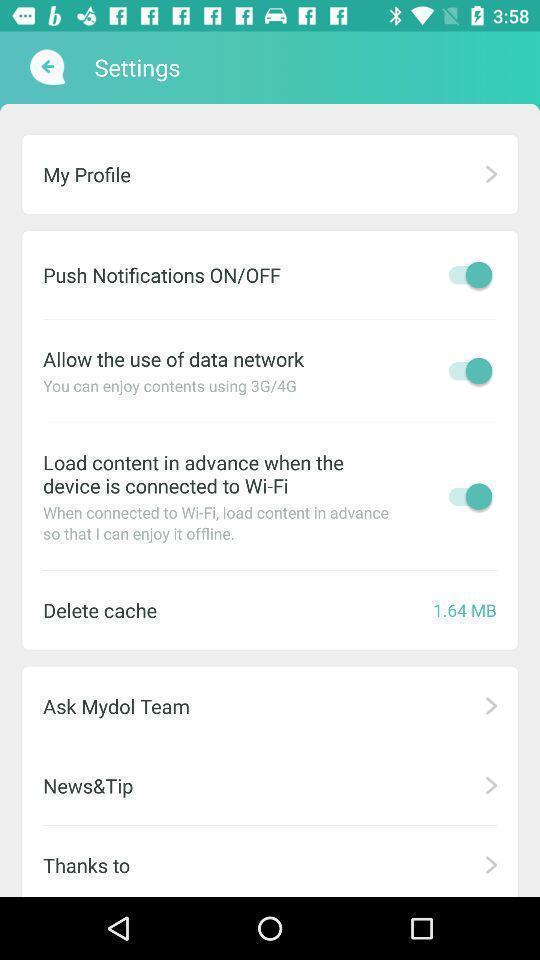Describe the key features of this screenshot. Settings page. 